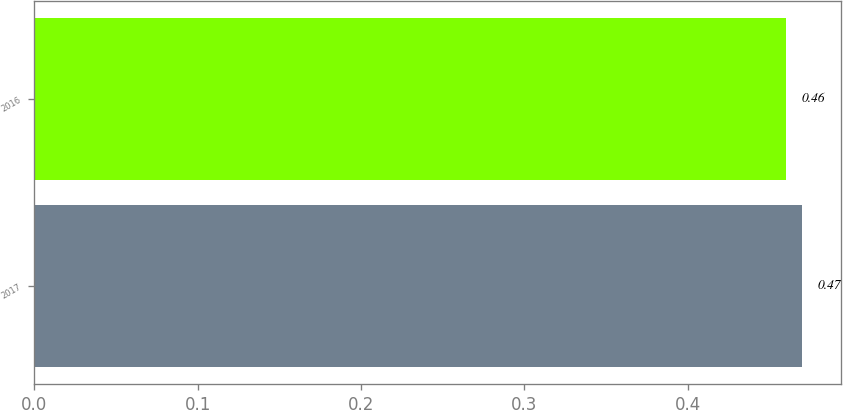<chart> <loc_0><loc_0><loc_500><loc_500><bar_chart><fcel>2017<fcel>2016<nl><fcel>0.47<fcel>0.46<nl></chart> 